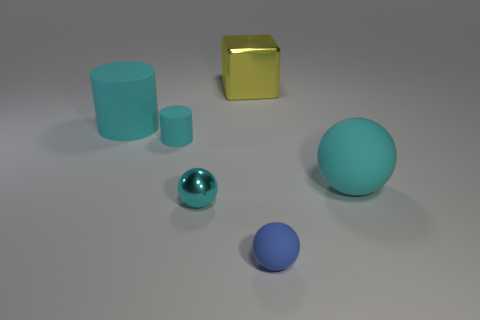What number of objects are tiny things that are on the left side of the tiny blue ball or red rubber cylinders?
Offer a terse response. 2. What shape is the matte object that is in front of the large rubber thing that is on the right side of the large object that is left of the cyan metal thing?
Your response must be concise. Sphere. How many other metal objects are the same shape as the tiny metallic thing?
Your answer should be very brief. 0. What material is the large object that is the same color as the big cylinder?
Your response must be concise. Rubber. Is the material of the big yellow block the same as the large cylinder?
Ensure brevity in your answer.  No. How many rubber cylinders are to the right of the big thing behind the cyan thing that is behind the tiny cyan cylinder?
Make the answer very short. 0. Are there any small purple cubes that have the same material as the big yellow block?
Your response must be concise. No. There is a shiny object that is the same color as the big cylinder; what is its size?
Provide a short and direct response. Small. Are there fewer tiny gray matte blocks than tiny cyan things?
Offer a terse response. Yes. Does the big object that is behind the big cyan matte cylinder have the same color as the tiny matte cylinder?
Offer a very short reply. No. 